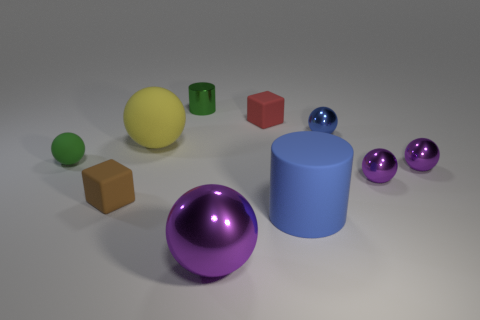Are there the same number of cylinders behind the green cylinder and red things on the right side of the red rubber block?
Ensure brevity in your answer.  Yes. What is the color of the block that is made of the same material as the brown object?
Give a very brief answer. Red. Is there a large sphere that has the same material as the small red thing?
Your answer should be compact. Yes. How many things are either tiny purple spheres or tiny red things?
Keep it short and to the point. 3. Is the large yellow thing made of the same material as the cylinder to the left of the large metal sphere?
Offer a very short reply. No. There is a purple shiny ball on the left side of the blue ball; how big is it?
Offer a very short reply. Large. Is the number of large yellow spheres less than the number of matte blocks?
Offer a very short reply. Yes. Are there any other big cylinders that have the same color as the metal cylinder?
Your answer should be compact. No. What is the shape of the thing that is both in front of the tiny green metal cylinder and behind the blue metallic thing?
Provide a succinct answer. Cube. There is a rubber thing in front of the cube in front of the tiny green rubber sphere; what is its shape?
Give a very brief answer. Cylinder. 